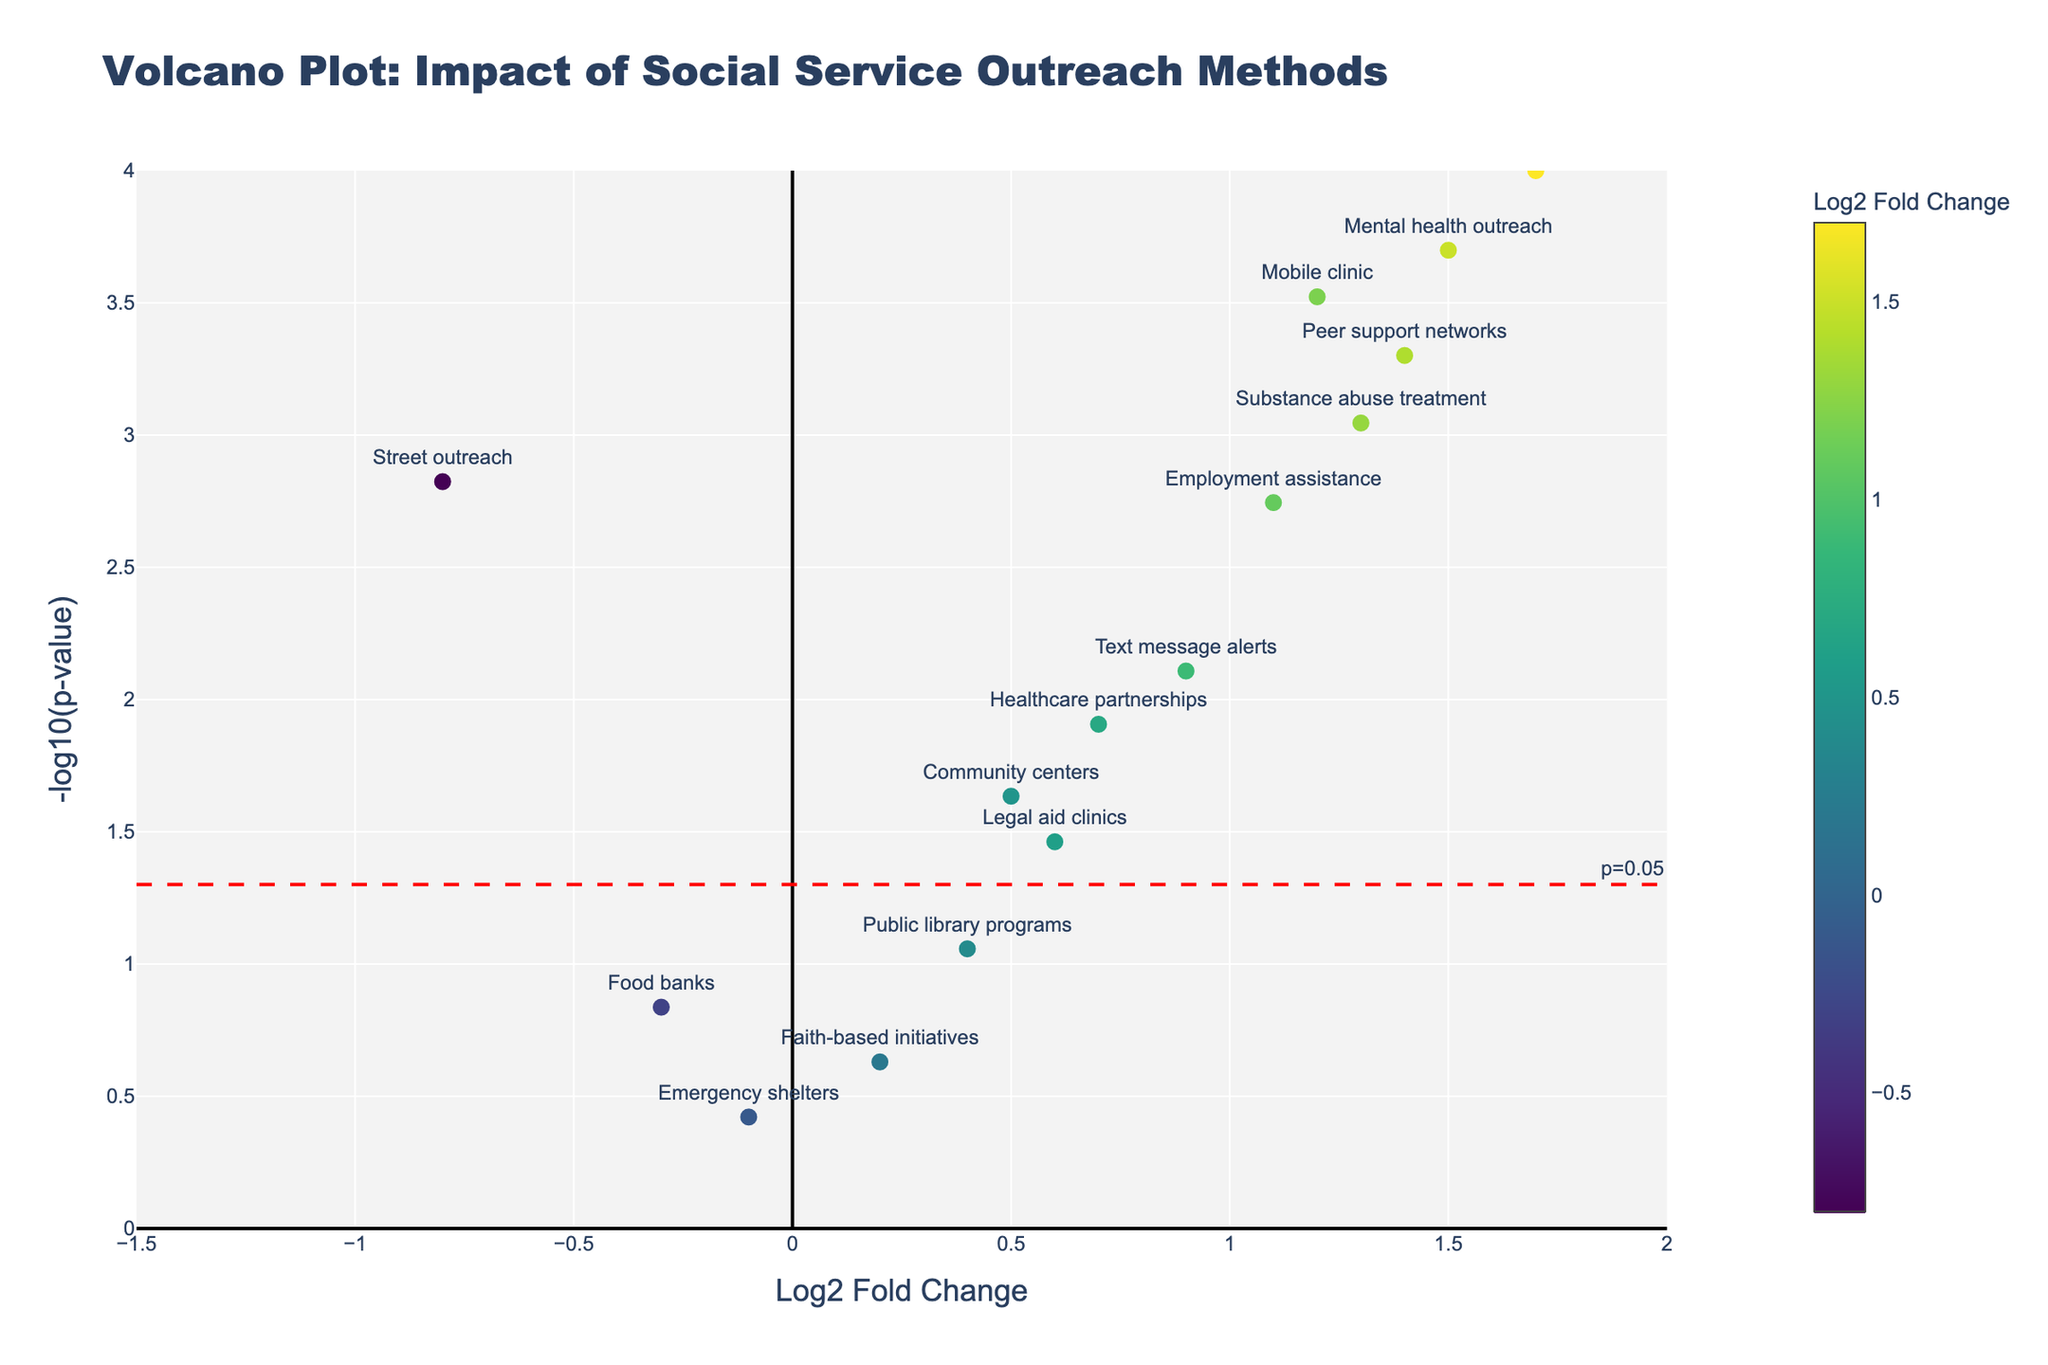What is the title of the Volcano Plot? The title is displayed prominently at the top of the figure and provides an overview of the plot's purpose.
Answer: Volcano Plot: Impact of Social Service Outreach Methods Which social service outreach method shows the highest engagement rate? The highest engagement rate corresponds to the method with the highest Log2 Fold Change. In this plot, it is represented by the highest point on the x-axis to the right.
Answer: Social media campaigns How many methods show a negative Log2 Fold Change? Count the number of data points positioned to the left of the zero on the x-axis. These represent methods with a negative Log2 Fold Change.
Answer: Three methods (Street outreach, Food banks, Emergency shelters) Which methods have a p-value below the threshold of 0.05? The red dashed line represents the p-value threshold of 0.05, and any point above this line has a p-value below 0.05. Identify these points.
Answer: Street outreach, Mobile clinic, Social media campaigns, Text message alerts, Peer support networks, Healthcare partnerships, Employment assistance, Substance abuse treatment, Mental health outreach, Legal aid clinics What is the Log2 Fold Change for the method "Mental health outreach"? Locate the "Mental health outreach" data point and read its position on the x-axis.
Answer: 1.5 Which method has the lowest p-value and what is it? The lowest p-value corresponds to the point with the highest value on the y-axis. Identify the method and its p-value from the hover text.
Answer: Social media campaigns, p-value = 0.0001 Compare the engagement rates (Log2 Fold Change) between "Mobile clinic" and "Text message alerts". Locate the data points for both methods and compare their positions on the x-axis.
Answer: Mobile clinic has a higher Log2 Fold Change (1.2 vs. 0.9) Are there any methods with a Log2 Fold Change exactly at or below zero and a p-value below 0.05? Look for data points on or to the left of zero on the x-axis and above the red dashed line. These indicate a p-value below 0.05 and non-positive Log2 Fold Change.
Answer: Street outreach Which method is closest to the average Log2 Fold Change of all methods? Calculate the average Log2 Fold Change of all methods and identify the data point closest to this value. The average is approximately 0.64, so find the closest method.
Answer: Legal aid clinics (Log2 Fold Change = 0.6) How many methods were analyzed in total? Count the total number of data points plotted on the figure.
Answer: Fifteen methods 